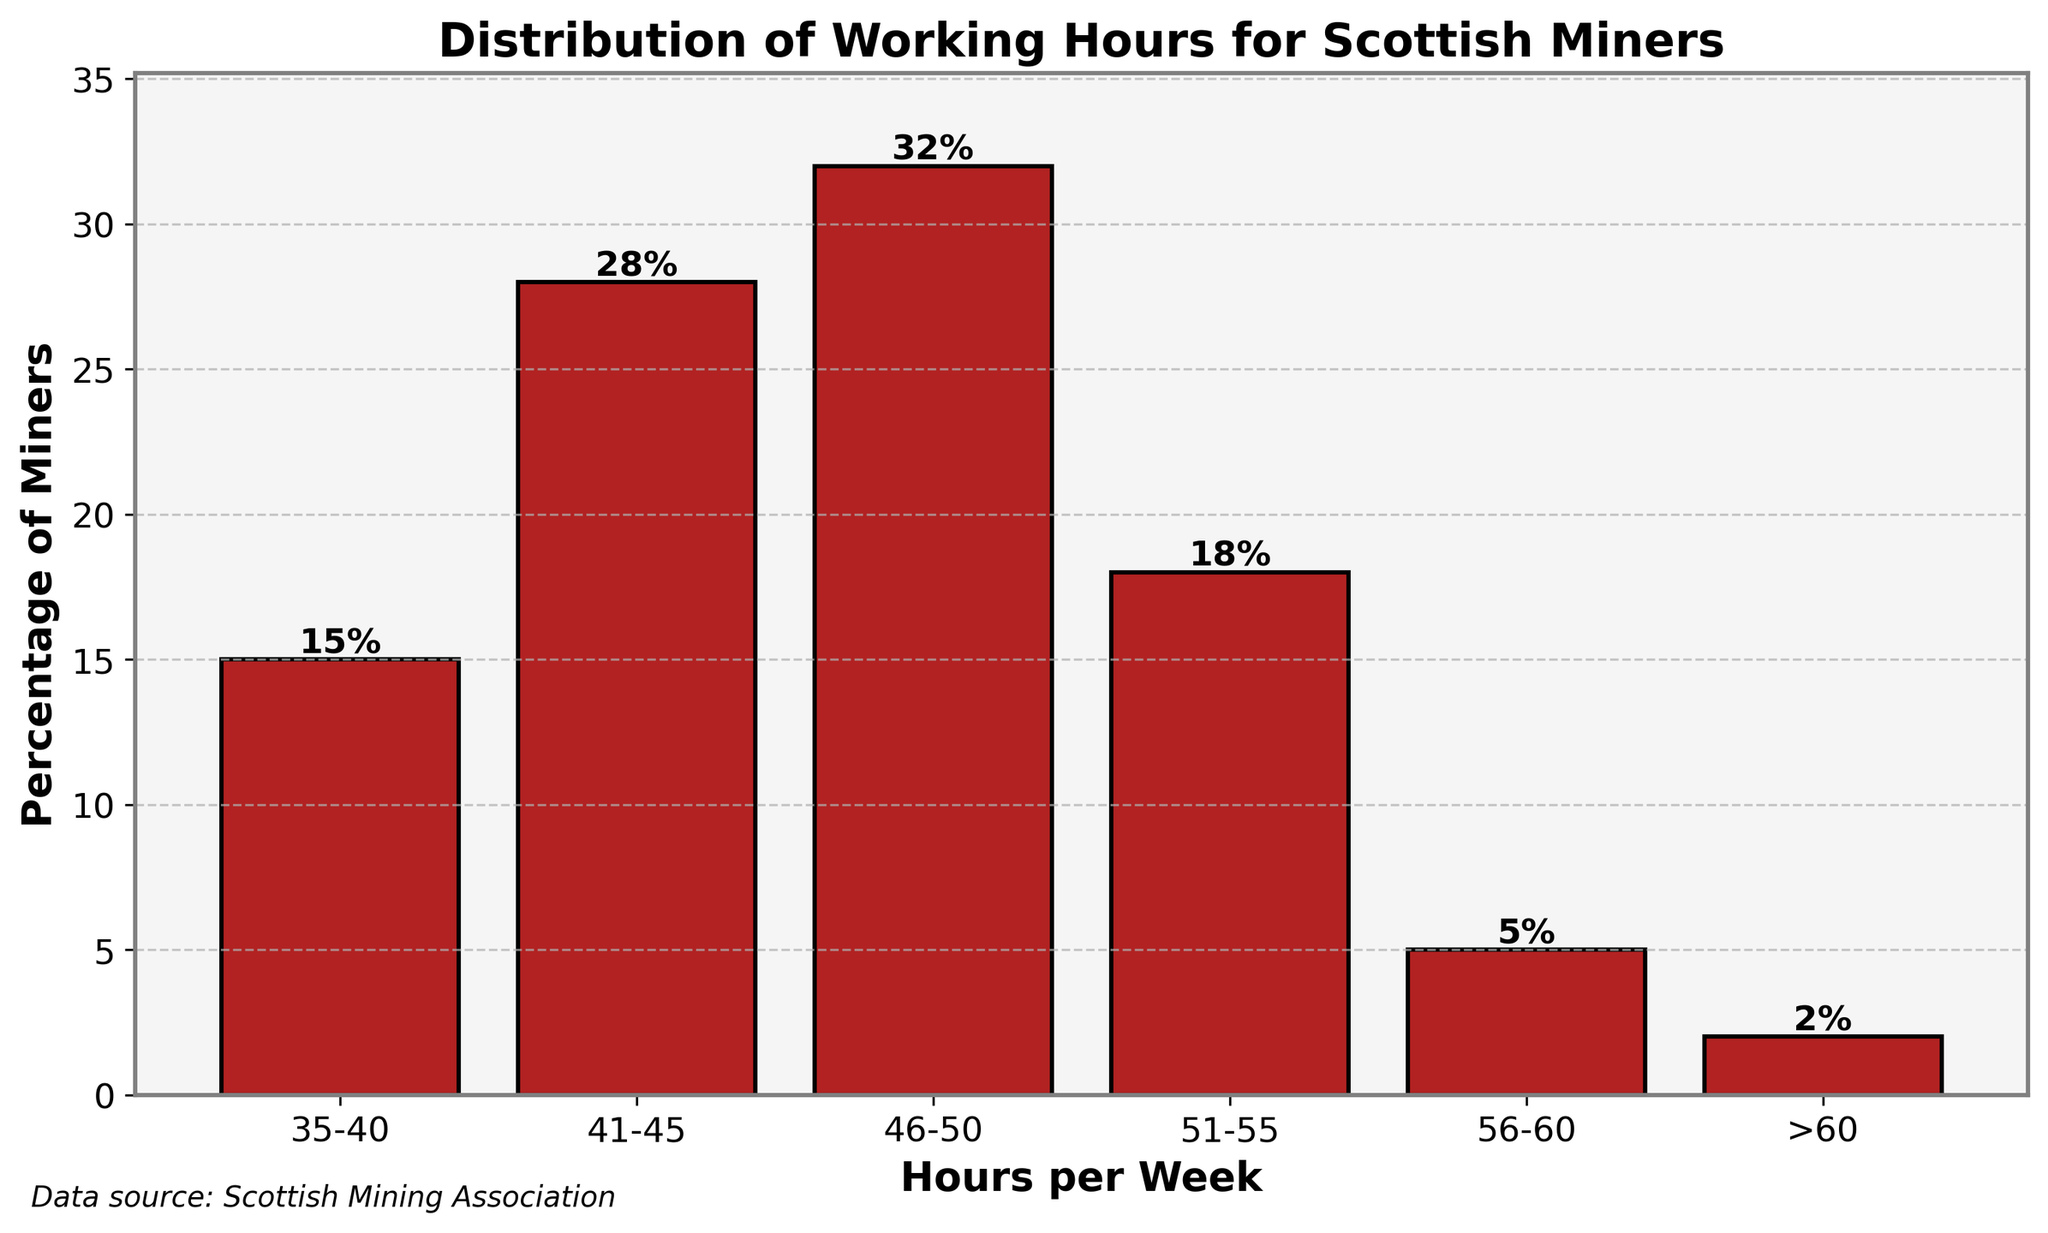What percentage of miners work more than 55 hours per week? Sum the percentages for the ranges "56-60" and ">60". That is 5% + 2% = 7%.
Answer: 7% Which range of working hours has the smallest percentage of miners? Compare the percentages of all the ranges. The range with the smallest percentage is ">60" with 2%.
Answer: >60 How many times larger is the percentage of miners working 46-50 hours compared to those working 56-60 hours? Divide the percentage of miners working 46-50 hours (32%) by those working 56-60 hours (5%). That is 32/5 = 6.4 times larger.
Answer: 6.4 Is the percentage of miners working 41-45 hours greater than the percentage of those working 51-55 hours? Compare the percentages: 41-45 hours (28%) and 51-55 hours (18%). Since 28% > 18%, the answer is yes.
Answer: Yes What are the total percentage of miners working between 35 and 50 hours per week? Add the percentages for the ranges "35-40", "41-45", and "46-50". That is 15% + 28% + 32% = 75%.
Answer: 75% Which range of working hours has the tallest bar in the chart? Identify the bar with the greatest height, which corresponds to the range "46-50" hours with 32%.
Answer: 46-50 How much higher is the percentage of miners working 46-50 hours compared to those working 35-40 hours? Subtract the percentage of the "35-40" range from "46-50" range. That is 32% - 15% = 17%.
Answer: 17% Which range has a visual length closest to 20% in the chart? Compare the visual lengths of the bars to 20%. The "51-55" range has a length of 18%, which is closest to 20%.
Answer: 51-55 What is the average percentage of miners working between 41 and 60 hours per week? Average (28% + 32% + 18% + 5%) is calculated as (28 + 32 + 18 + 5) / 4 = 83 / 4 = 20.75%.
Answer: 20.75% Does any range exceed 30% in miner percentage? If so, which one? Identify any range with a percentage greater than 30%. The "46-50" range has 32%, which exceeds 30%.
Answer: 46-50 